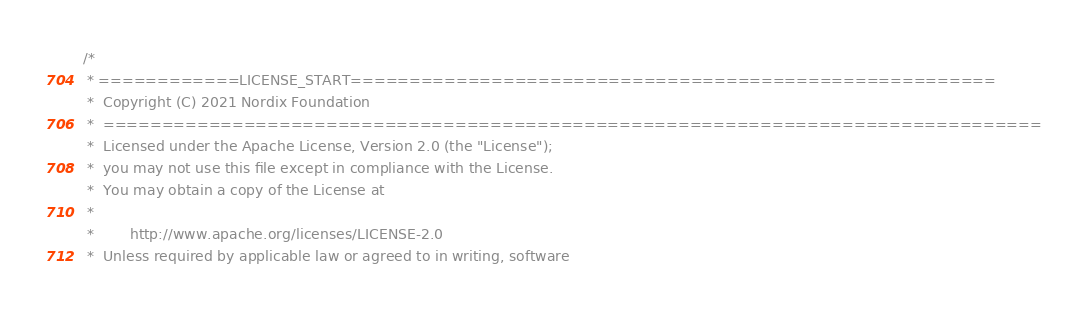<code> <loc_0><loc_0><loc_500><loc_500><_SQL_>/*
 * ============LICENSE_START=======================================================
 *  Copyright (C) 2021 Nordix Foundation
 *  ================================================================================
 *  Licensed under the Apache License, Version 2.0 (the "License");
 *  you may not use this file except in compliance with the License.
 *  You may obtain a copy of the License at
 *
 *        http://www.apache.org/licenses/LICENSE-2.0
 *  Unless required by applicable law or agreed to in writing, software</code> 